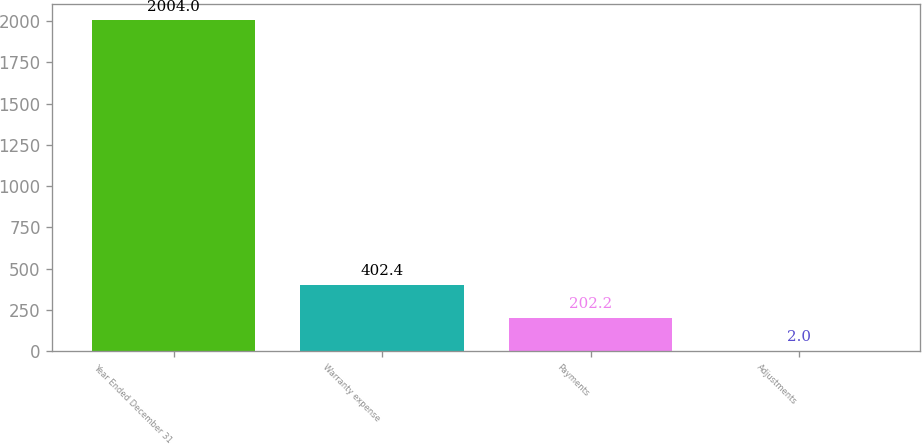Convert chart. <chart><loc_0><loc_0><loc_500><loc_500><bar_chart><fcel>Year Ended December 31<fcel>Warranty expense<fcel>Payments<fcel>Adjustments<nl><fcel>2004<fcel>402.4<fcel>202.2<fcel>2<nl></chart> 